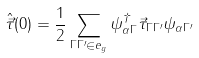Convert formula to latex. <formula><loc_0><loc_0><loc_500><loc_500>\hat { \vec { \tau } } ( 0 ) = \frac { 1 } { 2 } \sum _ { \Gamma \Gamma ^ { \prime } \in e _ { g } } \psi _ { \alpha \Gamma } ^ { \dagger } \vec { \tau } _ { \Gamma \Gamma ^ { \prime } } \psi _ { \alpha \Gamma ^ { \prime } }</formula> 